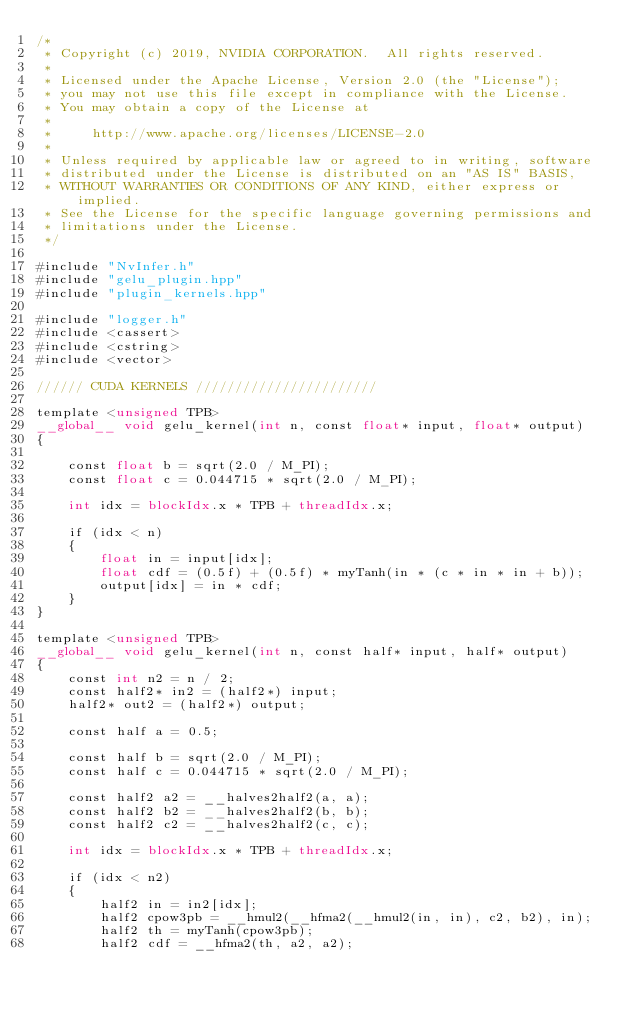<code> <loc_0><loc_0><loc_500><loc_500><_Cuda_>/*
 * Copyright (c) 2019, NVIDIA CORPORATION.  All rights reserved.
 *
 * Licensed under the Apache License, Version 2.0 (the "License");
 * you may not use this file except in compliance with the License.
 * You may obtain a copy of the License at
 *
 *     http://www.apache.org/licenses/LICENSE-2.0
 *
 * Unless required by applicable law or agreed to in writing, software
 * distributed under the License is distributed on an "AS IS" BASIS,
 * WITHOUT WARRANTIES OR CONDITIONS OF ANY KIND, either express or implied.
 * See the License for the specific language governing permissions and
 * limitations under the License.
 */

#include "NvInfer.h"
#include "gelu_plugin.hpp"
#include "plugin_kernels.hpp"

#include "logger.h"
#include <cassert>
#include <cstring>
#include <vector>

////// CUDA KERNELS ///////////////////////

template <unsigned TPB>
__global__ void gelu_kernel(int n, const float* input, float* output)
{

    const float b = sqrt(2.0 / M_PI);
    const float c = 0.044715 * sqrt(2.0 / M_PI);

    int idx = blockIdx.x * TPB + threadIdx.x;

    if (idx < n)
    {
        float in = input[idx];
        float cdf = (0.5f) + (0.5f) * myTanh(in * (c * in * in + b));
        output[idx] = in * cdf;
    }
}

template <unsigned TPB>
__global__ void gelu_kernel(int n, const half* input, half* output)
{
    const int n2 = n / 2;
    const half2* in2 = (half2*) input;
    half2* out2 = (half2*) output;

    const half a = 0.5;

    const half b = sqrt(2.0 / M_PI);
    const half c = 0.044715 * sqrt(2.0 / M_PI);

    const half2 a2 = __halves2half2(a, a);
    const half2 b2 = __halves2half2(b, b);
    const half2 c2 = __halves2half2(c, c);

    int idx = blockIdx.x * TPB + threadIdx.x;

    if (idx < n2)
    {
        half2 in = in2[idx];
        half2 cpow3pb = __hmul2(__hfma2(__hmul2(in, in), c2, b2), in);
        half2 th = myTanh(cpow3pb);
        half2 cdf = __hfma2(th, a2, a2);</code> 